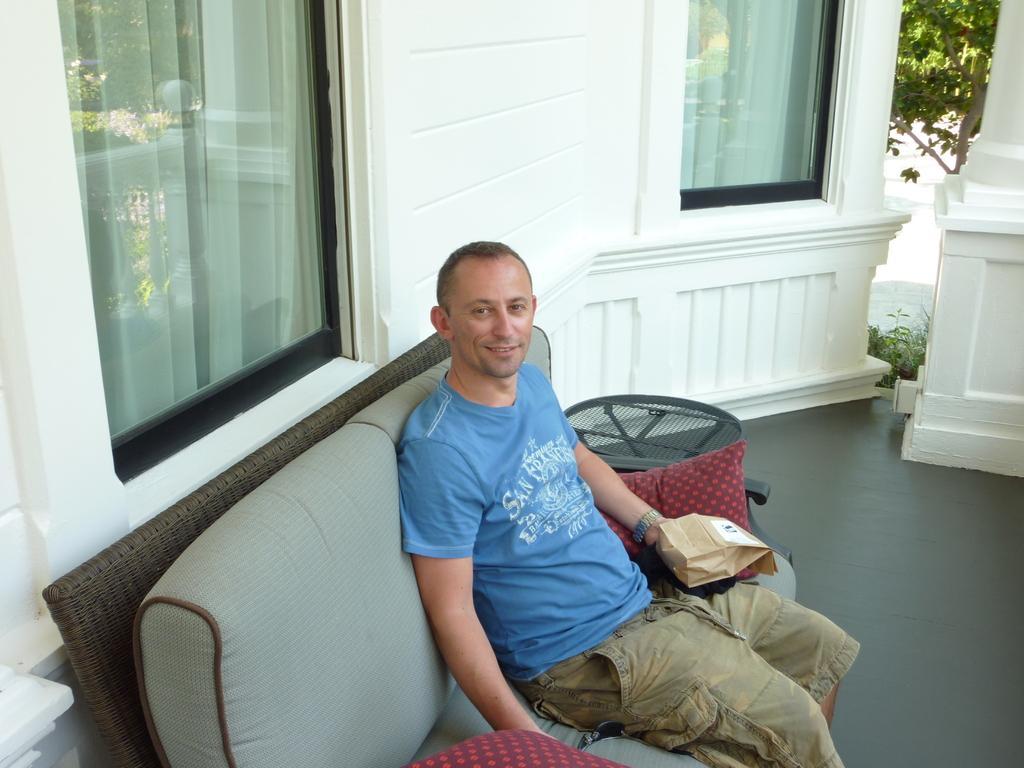Can you describe this image briefly? In this image there is a person sitting on the sofa by holding a bag in his hand, besides the person there are cushions, beside the sofa there is an object, behind the person there are windows on the wall and there is a pillar and a tree and plants. 